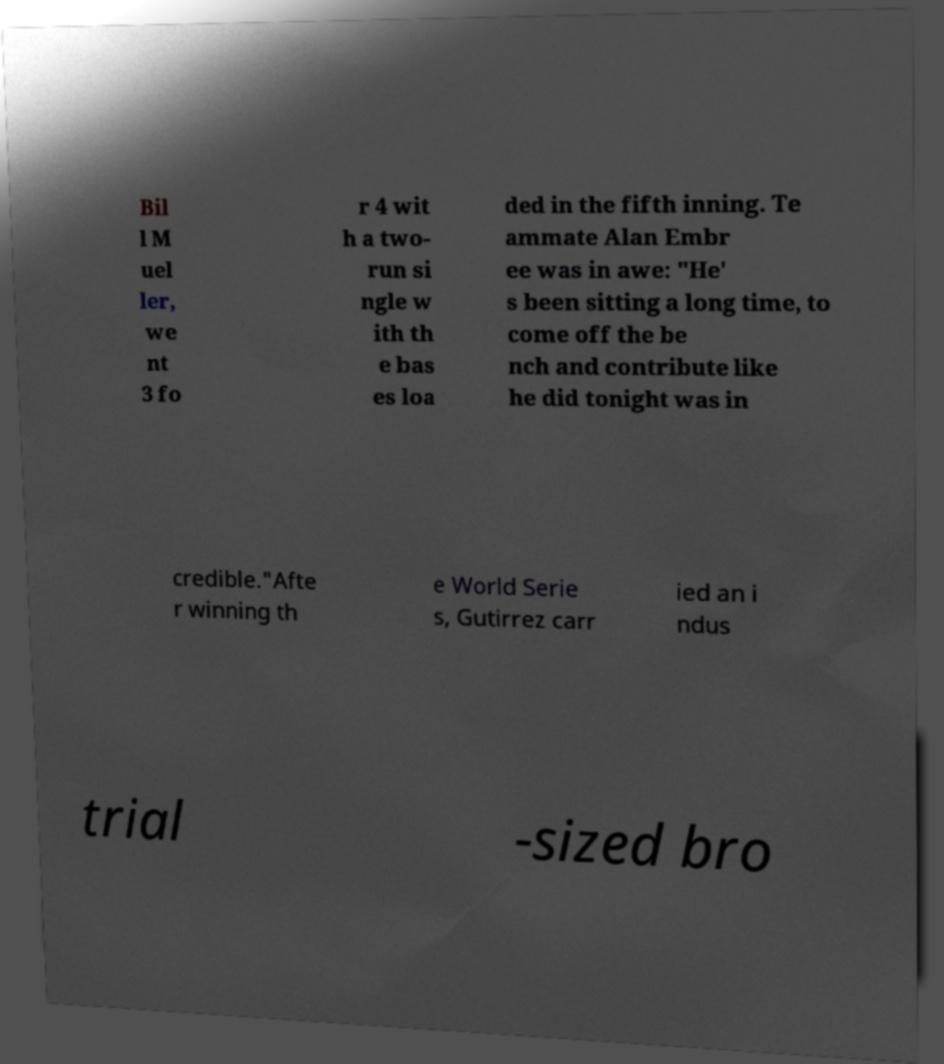Can you read and provide the text displayed in the image?This photo seems to have some interesting text. Can you extract and type it out for me? Bil l M uel ler, we nt 3 fo r 4 wit h a two- run si ngle w ith th e bas es loa ded in the fifth inning. Te ammate Alan Embr ee was in awe: "He' s been sitting a long time, to come off the be nch and contribute like he did tonight was in credible."Afte r winning th e World Serie s, Gutirrez carr ied an i ndus trial -sized bro 